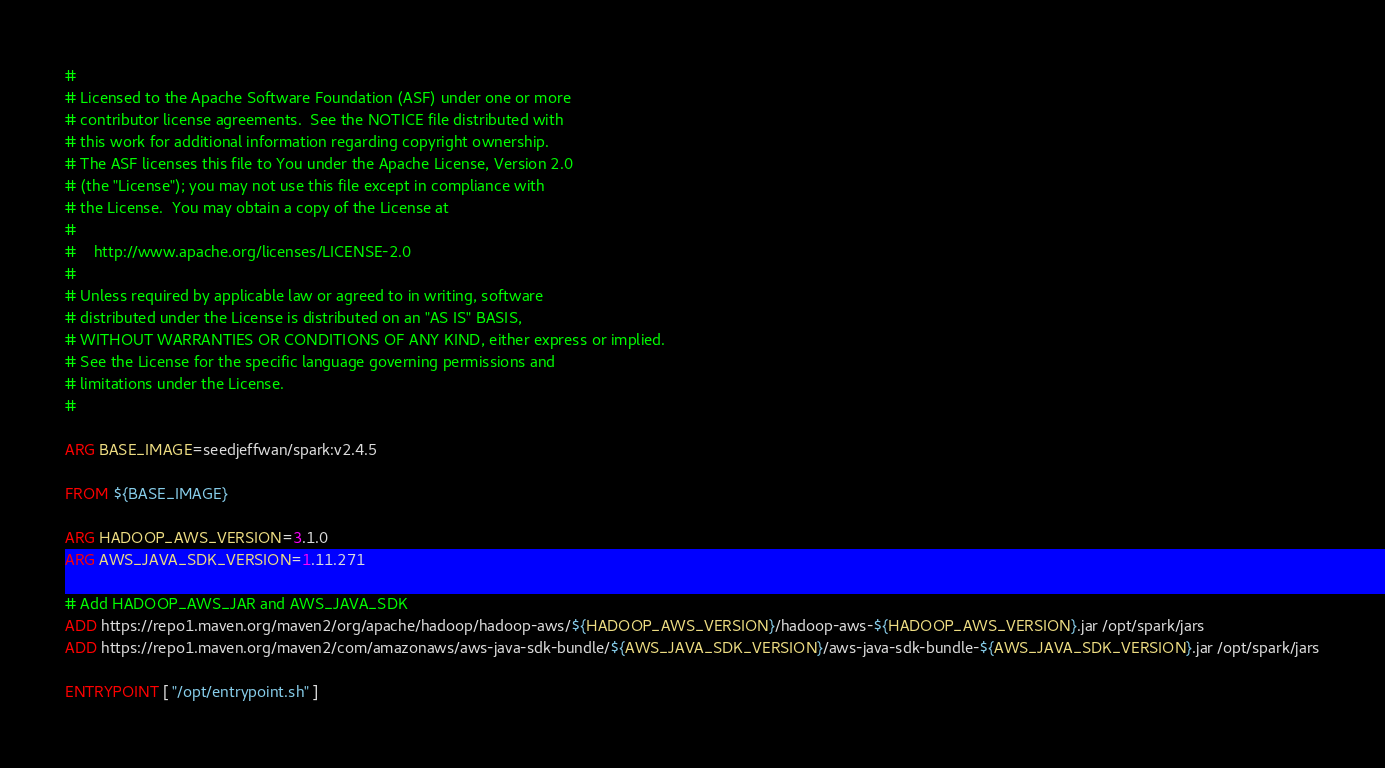Convert code to text. <code><loc_0><loc_0><loc_500><loc_500><_Dockerfile_>#
# Licensed to the Apache Software Foundation (ASF) under one or more
# contributor license agreements.  See the NOTICE file distributed with
# this work for additional information regarding copyright ownership.
# The ASF licenses this file to You under the Apache License, Version 2.0
# (the "License"); you may not use this file except in compliance with
# the License.  You may obtain a copy of the License at
#
#    http://www.apache.org/licenses/LICENSE-2.0
#
# Unless required by applicable law or agreed to in writing, software
# distributed under the License is distributed on an "AS IS" BASIS,
# WITHOUT WARRANTIES OR CONDITIONS OF ANY KIND, either express or implied.
# See the License for the specific language governing permissions and
# limitations under the License.
#

ARG BASE_IMAGE=seedjeffwan/spark:v2.4.5

FROM ${BASE_IMAGE}

ARG HADOOP_AWS_VERSION=3.1.0
ARG AWS_JAVA_SDK_VERSION=1.11.271

# Add HADOOP_AWS_JAR and AWS_JAVA_SDK
ADD https://repo1.maven.org/maven2/org/apache/hadoop/hadoop-aws/${HADOOP_AWS_VERSION}/hadoop-aws-${HADOOP_AWS_VERSION}.jar /opt/spark/jars
ADD https://repo1.maven.org/maven2/com/amazonaws/aws-java-sdk-bundle/${AWS_JAVA_SDK_VERSION}/aws-java-sdk-bundle-${AWS_JAVA_SDK_VERSION}.jar /opt/spark/jars

ENTRYPOINT [ "/opt/entrypoint.sh" ]</code> 